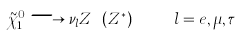<formula> <loc_0><loc_0><loc_500><loc_500>\tilde { \chi } ^ { 0 } _ { 1 } \longrightarrow \nu _ { l } Z \ ( Z ^ { * } ) \quad \ l = e , \mu , \tau</formula> 